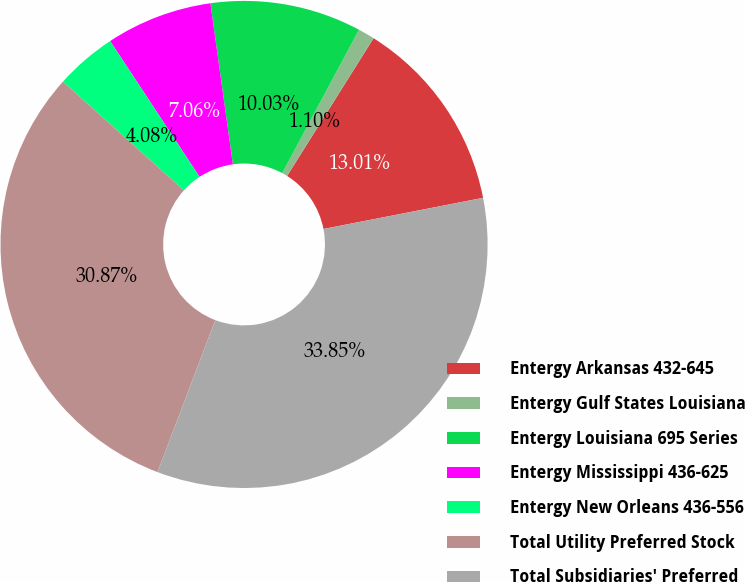<chart> <loc_0><loc_0><loc_500><loc_500><pie_chart><fcel>Entergy Arkansas 432-645<fcel>Entergy Gulf States Louisiana<fcel>Entergy Louisiana 695 Series<fcel>Entergy Mississippi 436-625<fcel>Entergy New Orleans 436-556<fcel>Total Utility Preferred Stock<fcel>Total Subsidiaries' Preferred<nl><fcel>13.01%<fcel>1.1%<fcel>10.03%<fcel>7.06%<fcel>4.08%<fcel>30.87%<fcel>33.85%<nl></chart> 